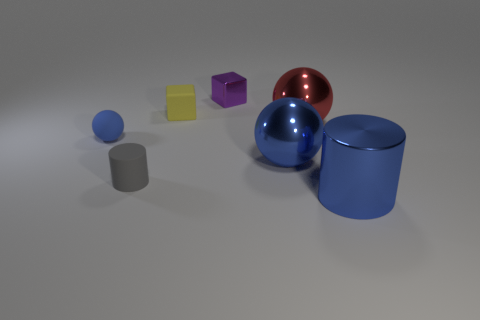Can you describe the grouping of objects on the left? Certainly! The grouping on the left consists of a small blue sphere and a grey cylinder, both resting on the surface and likely indicating an exploration of geometric shapes and different sizes. 